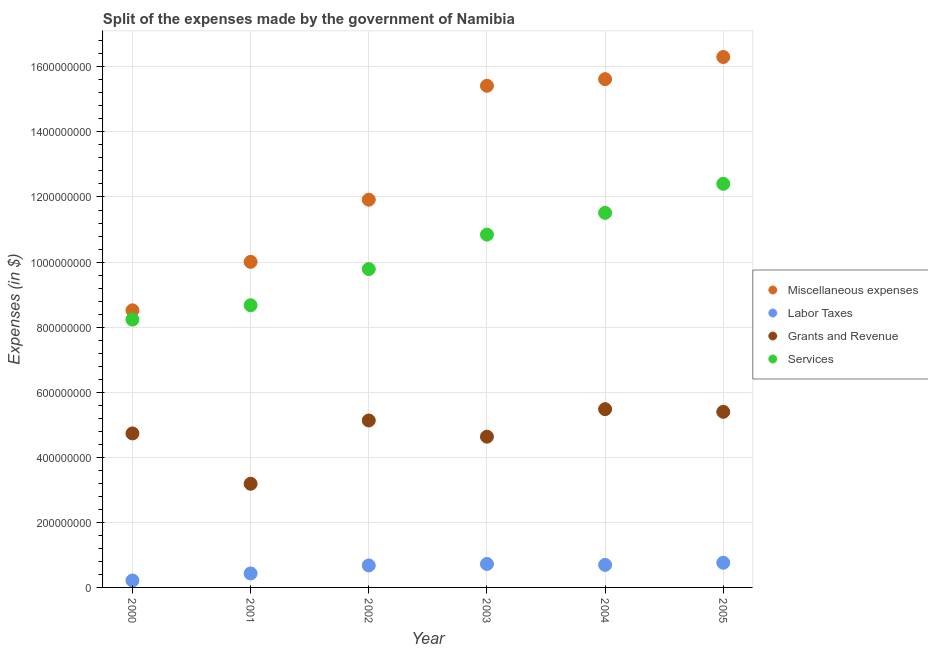Is the number of dotlines equal to the number of legend labels?
Offer a terse response. Yes. What is the amount spent on grants and revenue in 2001?
Give a very brief answer. 3.19e+08. Across all years, what is the maximum amount spent on labor taxes?
Keep it short and to the point. 7.58e+07. Across all years, what is the minimum amount spent on services?
Give a very brief answer. 8.23e+08. In which year was the amount spent on services minimum?
Make the answer very short. 2000. What is the total amount spent on miscellaneous expenses in the graph?
Your answer should be compact. 7.78e+09. What is the difference between the amount spent on services in 2000 and that in 2003?
Ensure brevity in your answer.  -2.61e+08. What is the difference between the amount spent on miscellaneous expenses in 2001 and the amount spent on grants and revenue in 2000?
Provide a succinct answer. 5.27e+08. What is the average amount spent on grants and revenue per year?
Provide a succinct answer. 4.76e+08. In the year 2004, what is the difference between the amount spent on miscellaneous expenses and amount spent on services?
Your response must be concise. 4.11e+08. In how many years, is the amount spent on services greater than 120000000 $?
Provide a short and direct response. 6. What is the ratio of the amount spent on labor taxes in 2002 to that in 2004?
Keep it short and to the point. 0.98. Is the amount spent on miscellaneous expenses in 2004 less than that in 2005?
Offer a terse response. Yes. Is the difference between the amount spent on grants and revenue in 2000 and 2005 greater than the difference between the amount spent on miscellaneous expenses in 2000 and 2005?
Offer a terse response. Yes. What is the difference between the highest and the second highest amount spent on grants and revenue?
Your answer should be very brief. 8.20e+06. What is the difference between the highest and the lowest amount spent on grants and revenue?
Keep it short and to the point. 2.29e+08. In how many years, is the amount spent on miscellaneous expenses greater than the average amount spent on miscellaneous expenses taken over all years?
Offer a terse response. 3. Is the sum of the amount spent on miscellaneous expenses in 2000 and 2005 greater than the maximum amount spent on labor taxes across all years?
Keep it short and to the point. Yes. Is it the case that in every year, the sum of the amount spent on miscellaneous expenses and amount spent on services is greater than the sum of amount spent on grants and revenue and amount spent on labor taxes?
Your answer should be very brief. No. Does the amount spent on services monotonically increase over the years?
Offer a very short reply. Yes. Is the amount spent on labor taxes strictly greater than the amount spent on services over the years?
Your response must be concise. No. How many dotlines are there?
Ensure brevity in your answer.  4. How many years are there in the graph?
Your answer should be compact. 6. Are the values on the major ticks of Y-axis written in scientific E-notation?
Give a very brief answer. No. Does the graph contain any zero values?
Provide a short and direct response. No. Where does the legend appear in the graph?
Offer a terse response. Center right. How many legend labels are there?
Offer a very short reply. 4. How are the legend labels stacked?
Ensure brevity in your answer.  Vertical. What is the title of the graph?
Provide a short and direct response. Split of the expenses made by the government of Namibia. Does "Water" appear as one of the legend labels in the graph?
Provide a succinct answer. No. What is the label or title of the X-axis?
Ensure brevity in your answer.  Year. What is the label or title of the Y-axis?
Provide a short and direct response. Expenses (in $). What is the Expenses (in $) of Miscellaneous expenses in 2000?
Keep it short and to the point. 8.52e+08. What is the Expenses (in $) in Labor Taxes in 2000?
Make the answer very short. 2.13e+07. What is the Expenses (in $) in Grants and Revenue in 2000?
Provide a succinct answer. 4.73e+08. What is the Expenses (in $) in Services in 2000?
Your answer should be compact. 8.23e+08. What is the Expenses (in $) of Miscellaneous expenses in 2001?
Your answer should be very brief. 1.00e+09. What is the Expenses (in $) in Labor Taxes in 2001?
Your answer should be very brief. 4.30e+07. What is the Expenses (in $) in Grants and Revenue in 2001?
Give a very brief answer. 3.19e+08. What is the Expenses (in $) of Services in 2001?
Your answer should be compact. 8.67e+08. What is the Expenses (in $) of Miscellaneous expenses in 2002?
Provide a short and direct response. 1.19e+09. What is the Expenses (in $) of Labor Taxes in 2002?
Ensure brevity in your answer.  6.76e+07. What is the Expenses (in $) of Grants and Revenue in 2002?
Your response must be concise. 5.13e+08. What is the Expenses (in $) in Services in 2002?
Provide a short and direct response. 9.78e+08. What is the Expenses (in $) in Miscellaneous expenses in 2003?
Your response must be concise. 1.54e+09. What is the Expenses (in $) in Labor Taxes in 2003?
Ensure brevity in your answer.  7.21e+07. What is the Expenses (in $) in Grants and Revenue in 2003?
Your response must be concise. 4.63e+08. What is the Expenses (in $) of Services in 2003?
Keep it short and to the point. 1.08e+09. What is the Expenses (in $) in Miscellaneous expenses in 2004?
Ensure brevity in your answer.  1.56e+09. What is the Expenses (in $) of Labor Taxes in 2004?
Give a very brief answer. 6.93e+07. What is the Expenses (in $) of Grants and Revenue in 2004?
Ensure brevity in your answer.  5.48e+08. What is the Expenses (in $) in Services in 2004?
Your answer should be very brief. 1.15e+09. What is the Expenses (in $) in Miscellaneous expenses in 2005?
Your response must be concise. 1.63e+09. What is the Expenses (in $) of Labor Taxes in 2005?
Your answer should be compact. 7.58e+07. What is the Expenses (in $) of Grants and Revenue in 2005?
Offer a very short reply. 5.40e+08. What is the Expenses (in $) in Services in 2005?
Make the answer very short. 1.24e+09. Across all years, what is the maximum Expenses (in $) in Miscellaneous expenses?
Your response must be concise. 1.63e+09. Across all years, what is the maximum Expenses (in $) of Labor Taxes?
Your answer should be compact. 7.58e+07. Across all years, what is the maximum Expenses (in $) of Grants and Revenue?
Your answer should be very brief. 5.48e+08. Across all years, what is the maximum Expenses (in $) in Services?
Give a very brief answer. 1.24e+09. Across all years, what is the minimum Expenses (in $) of Miscellaneous expenses?
Offer a terse response. 8.52e+08. Across all years, what is the minimum Expenses (in $) of Labor Taxes?
Ensure brevity in your answer.  2.13e+07. Across all years, what is the minimum Expenses (in $) in Grants and Revenue?
Keep it short and to the point. 3.19e+08. Across all years, what is the minimum Expenses (in $) of Services?
Your answer should be very brief. 8.23e+08. What is the total Expenses (in $) of Miscellaneous expenses in the graph?
Offer a very short reply. 7.78e+09. What is the total Expenses (in $) in Labor Taxes in the graph?
Provide a succinct answer. 3.49e+08. What is the total Expenses (in $) of Grants and Revenue in the graph?
Make the answer very short. 2.86e+09. What is the total Expenses (in $) of Services in the graph?
Ensure brevity in your answer.  6.15e+09. What is the difference between the Expenses (in $) in Miscellaneous expenses in 2000 and that in 2001?
Keep it short and to the point. -1.49e+08. What is the difference between the Expenses (in $) in Labor Taxes in 2000 and that in 2001?
Keep it short and to the point. -2.17e+07. What is the difference between the Expenses (in $) in Grants and Revenue in 2000 and that in 2001?
Your answer should be compact. 1.55e+08. What is the difference between the Expenses (in $) in Services in 2000 and that in 2001?
Give a very brief answer. -4.41e+07. What is the difference between the Expenses (in $) of Miscellaneous expenses in 2000 and that in 2002?
Provide a succinct answer. -3.40e+08. What is the difference between the Expenses (in $) of Labor Taxes in 2000 and that in 2002?
Make the answer very short. -4.63e+07. What is the difference between the Expenses (in $) of Grants and Revenue in 2000 and that in 2002?
Give a very brief answer. -3.98e+07. What is the difference between the Expenses (in $) of Services in 2000 and that in 2002?
Your answer should be very brief. -1.55e+08. What is the difference between the Expenses (in $) of Miscellaneous expenses in 2000 and that in 2003?
Provide a succinct answer. -6.90e+08. What is the difference between the Expenses (in $) of Labor Taxes in 2000 and that in 2003?
Your answer should be compact. -5.08e+07. What is the difference between the Expenses (in $) of Grants and Revenue in 2000 and that in 2003?
Offer a very short reply. 1.00e+07. What is the difference between the Expenses (in $) of Services in 2000 and that in 2003?
Your response must be concise. -2.61e+08. What is the difference between the Expenses (in $) of Miscellaneous expenses in 2000 and that in 2004?
Ensure brevity in your answer.  -7.11e+08. What is the difference between the Expenses (in $) of Labor Taxes in 2000 and that in 2004?
Provide a short and direct response. -4.80e+07. What is the difference between the Expenses (in $) in Grants and Revenue in 2000 and that in 2004?
Offer a very short reply. -7.46e+07. What is the difference between the Expenses (in $) of Services in 2000 and that in 2004?
Your response must be concise. -3.28e+08. What is the difference between the Expenses (in $) of Miscellaneous expenses in 2000 and that in 2005?
Keep it short and to the point. -7.79e+08. What is the difference between the Expenses (in $) of Labor Taxes in 2000 and that in 2005?
Your response must be concise. -5.45e+07. What is the difference between the Expenses (in $) of Grants and Revenue in 2000 and that in 2005?
Provide a short and direct response. -6.64e+07. What is the difference between the Expenses (in $) of Services in 2000 and that in 2005?
Provide a short and direct response. -4.17e+08. What is the difference between the Expenses (in $) in Miscellaneous expenses in 2001 and that in 2002?
Make the answer very short. -1.91e+08. What is the difference between the Expenses (in $) of Labor Taxes in 2001 and that in 2002?
Provide a succinct answer. -2.46e+07. What is the difference between the Expenses (in $) of Grants and Revenue in 2001 and that in 2002?
Make the answer very short. -1.94e+08. What is the difference between the Expenses (in $) in Services in 2001 and that in 2002?
Provide a succinct answer. -1.11e+08. What is the difference between the Expenses (in $) of Miscellaneous expenses in 2001 and that in 2003?
Offer a terse response. -5.41e+08. What is the difference between the Expenses (in $) of Labor Taxes in 2001 and that in 2003?
Keep it short and to the point. -2.91e+07. What is the difference between the Expenses (in $) of Grants and Revenue in 2001 and that in 2003?
Your answer should be compact. -1.45e+08. What is the difference between the Expenses (in $) in Services in 2001 and that in 2003?
Give a very brief answer. -2.17e+08. What is the difference between the Expenses (in $) of Miscellaneous expenses in 2001 and that in 2004?
Your answer should be compact. -5.62e+08. What is the difference between the Expenses (in $) in Labor Taxes in 2001 and that in 2004?
Your response must be concise. -2.63e+07. What is the difference between the Expenses (in $) in Grants and Revenue in 2001 and that in 2004?
Provide a short and direct response. -2.29e+08. What is the difference between the Expenses (in $) of Services in 2001 and that in 2004?
Your response must be concise. -2.84e+08. What is the difference between the Expenses (in $) in Miscellaneous expenses in 2001 and that in 2005?
Provide a short and direct response. -6.30e+08. What is the difference between the Expenses (in $) in Labor Taxes in 2001 and that in 2005?
Your response must be concise. -3.28e+07. What is the difference between the Expenses (in $) of Grants and Revenue in 2001 and that in 2005?
Ensure brevity in your answer.  -2.21e+08. What is the difference between the Expenses (in $) of Services in 2001 and that in 2005?
Give a very brief answer. -3.73e+08. What is the difference between the Expenses (in $) in Miscellaneous expenses in 2002 and that in 2003?
Offer a terse response. -3.50e+08. What is the difference between the Expenses (in $) of Labor Taxes in 2002 and that in 2003?
Offer a very short reply. -4.50e+06. What is the difference between the Expenses (in $) in Grants and Revenue in 2002 and that in 2003?
Give a very brief answer. 4.98e+07. What is the difference between the Expenses (in $) in Services in 2002 and that in 2003?
Your answer should be compact. -1.06e+08. What is the difference between the Expenses (in $) of Miscellaneous expenses in 2002 and that in 2004?
Offer a terse response. -3.71e+08. What is the difference between the Expenses (in $) of Labor Taxes in 2002 and that in 2004?
Offer a very short reply. -1.70e+06. What is the difference between the Expenses (in $) of Grants and Revenue in 2002 and that in 2004?
Give a very brief answer. -3.48e+07. What is the difference between the Expenses (in $) of Services in 2002 and that in 2004?
Provide a succinct answer. -1.73e+08. What is the difference between the Expenses (in $) in Miscellaneous expenses in 2002 and that in 2005?
Provide a succinct answer. -4.39e+08. What is the difference between the Expenses (in $) in Labor Taxes in 2002 and that in 2005?
Your answer should be very brief. -8.20e+06. What is the difference between the Expenses (in $) of Grants and Revenue in 2002 and that in 2005?
Provide a succinct answer. -2.66e+07. What is the difference between the Expenses (in $) in Services in 2002 and that in 2005?
Provide a succinct answer. -2.62e+08. What is the difference between the Expenses (in $) in Miscellaneous expenses in 2003 and that in 2004?
Offer a terse response. -2.04e+07. What is the difference between the Expenses (in $) of Labor Taxes in 2003 and that in 2004?
Your answer should be very brief. 2.80e+06. What is the difference between the Expenses (in $) in Grants and Revenue in 2003 and that in 2004?
Make the answer very short. -8.46e+07. What is the difference between the Expenses (in $) in Services in 2003 and that in 2004?
Provide a short and direct response. -6.68e+07. What is the difference between the Expenses (in $) of Miscellaneous expenses in 2003 and that in 2005?
Offer a very short reply. -8.84e+07. What is the difference between the Expenses (in $) in Labor Taxes in 2003 and that in 2005?
Offer a very short reply. -3.70e+06. What is the difference between the Expenses (in $) of Grants and Revenue in 2003 and that in 2005?
Provide a succinct answer. -7.64e+07. What is the difference between the Expenses (in $) of Services in 2003 and that in 2005?
Make the answer very short. -1.56e+08. What is the difference between the Expenses (in $) in Miscellaneous expenses in 2004 and that in 2005?
Offer a very short reply. -6.80e+07. What is the difference between the Expenses (in $) in Labor Taxes in 2004 and that in 2005?
Provide a succinct answer. -6.50e+06. What is the difference between the Expenses (in $) of Grants and Revenue in 2004 and that in 2005?
Make the answer very short. 8.20e+06. What is the difference between the Expenses (in $) in Services in 2004 and that in 2005?
Your answer should be compact. -8.94e+07. What is the difference between the Expenses (in $) of Miscellaneous expenses in 2000 and the Expenses (in $) of Labor Taxes in 2001?
Give a very brief answer. 8.09e+08. What is the difference between the Expenses (in $) of Miscellaneous expenses in 2000 and the Expenses (in $) of Grants and Revenue in 2001?
Keep it short and to the point. 5.33e+08. What is the difference between the Expenses (in $) in Miscellaneous expenses in 2000 and the Expenses (in $) in Services in 2001?
Make the answer very short. -1.56e+07. What is the difference between the Expenses (in $) of Labor Taxes in 2000 and the Expenses (in $) of Grants and Revenue in 2001?
Your answer should be very brief. -2.97e+08. What is the difference between the Expenses (in $) in Labor Taxes in 2000 and the Expenses (in $) in Services in 2001?
Your answer should be compact. -8.46e+08. What is the difference between the Expenses (in $) in Grants and Revenue in 2000 and the Expenses (in $) in Services in 2001?
Your answer should be very brief. -3.94e+08. What is the difference between the Expenses (in $) in Miscellaneous expenses in 2000 and the Expenses (in $) in Labor Taxes in 2002?
Keep it short and to the point. 7.84e+08. What is the difference between the Expenses (in $) in Miscellaneous expenses in 2000 and the Expenses (in $) in Grants and Revenue in 2002?
Keep it short and to the point. 3.39e+08. What is the difference between the Expenses (in $) in Miscellaneous expenses in 2000 and the Expenses (in $) in Services in 2002?
Offer a very short reply. -1.27e+08. What is the difference between the Expenses (in $) of Labor Taxes in 2000 and the Expenses (in $) of Grants and Revenue in 2002?
Ensure brevity in your answer.  -4.92e+08. What is the difference between the Expenses (in $) of Labor Taxes in 2000 and the Expenses (in $) of Services in 2002?
Make the answer very short. -9.57e+08. What is the difference between the Expenses (in $) of Grants and Revenue in 2000 and the Expenses (in $) of Services in 2002?
Give a very brief answer. -5.05e+08. What is the difference between the Expenses (in $) in Miscellaneous expenses in 2000 and the Expenses (in $) in Labor Taxes in 2003?
Keep it short and to the point. 7.80e+08. What is the difference between the Expenses (in $) of Miscellaneous expenses in 2000 and the Expenses (in $) of Grants and Revenue in 2003?
Provide a succinct answer. 3.88e+08. What is the difference between the Expenses (in $) of Miscellaneous expenses in 2000 and the Expenses (in $) of Services in 2003?
Offer a very short reply. -2.33e+08. What is the difference between the Expenses (in $) in Labor Taxes in 2000 and the Expenses (in $) in Grants and Revenue in 2003?
Ensure brevity in your answer.  -4.42e+08. What is the difference between the Expenses (in $) of Labor Taxes in 2000 and the Expenses (in $) of Services in 2003?
Your answer should be compact. -1.06e+09. What is the difference between the Expenses (in $) in Grants and Revenue in 2000 and the Expenses (in $) in Services in 2003?
Offer a very short reply. -6.11e+08. What is the difference between the Expenses (in $) in Miscellaneous expenses in 2000 and the Expenses (in $) in Labor Taxes in 2004?
Your answer should be compact. 7.82e+08. What is the difference between the Expenses (in $) in Miscellaneous expenses in 2000 and the Expenses (in $) in Grants and Revenue in 2004?
Give a very brief answer. 3.04e+08. What is the difference between the Expenses (in $) in Miscellaneous expenses in 2000 and the Expenses (in $) in Services in 2004?
Provide a short and direct response. -3.00e+08. What is the difference between the Expenses (in $) of Labor Taxes in 2000 and the Expenses (in $) of Grants and Revenue in 2004?
Your answer should be compact. -5.27e+08. What is the difference between the Expenses (in $) in Labor Taxes in 2000 and the Expenses (in $) in Services in 2004?
Provide a succinct answer. -1.13e+09. What is the difference between the Expenses (in $) in Grants and Revenue in 2000 and the Expenses (in $) in Services in 2004?
Your response must be concise. -6.78e+08. What is the difference between the Expenses (in $) in Miscellaneous expenses in 2000 and the Expenses (in $) in Labor Taxes in 2005?
Your answer should be very brief. 7.76e+08. What is the difference between the Expenses (in $) in Miscellaneous expenses in 2000 and the Expenses (in $) in Grants and Revenue in 2005?
Provide a short and direct response. 3.12e+08. What is the difference between the Expenses (in $) in Miscellaneous expenses in 2000 and the Expenses (in $) in Services in 2005?
Offer a terse response. -3.89e+08. What is the difference between the Expenses (in $) of Labor Taxes in 2000 and the Expenses (in $) of Grants and Revenue in 2005?
Your response must be concise. -5.18e+08. What is the difference between the Expenses (in $) in Labor Taxes in 2000 and the Expenses (in $) in Services in 2005?
Ensure brevity in your answer.  -1.22e+09. What is the difference between the Expenses (in $) of Grants and Revenue in 2000 and the Expenses (in $) of Services in 2005?
Keep it short and to the point. -7.67e+08. What is the difference between the Expenses (in $) in Miscellaneous expenses in 2001 and the Expenses (in $) in Labor Taxes in 2002?
Your answer should be compact. 9.33e+08. What is the difference between the Expenses (in $) in Miscellaneous expenses in 2001 and the Expenses (in $) in Grants and Revenue in 2002?
Make the answer very short. 4.88e+08. What is the difference between the Expenses (in $) in Miscellaneous expenses in 2001 and the Expenses (in $) in Services in 2002?
Your response must be concise. 2.22e+07. What is the difference between the Expenses (in $) in Labor Taxes in 2001 and the Expenses (in $) in Grants and Revenue in 2002?
Your answer should be compact. -4.70e+08. What is the difference between the Expenses (in $) in Labor Taxes in 2001 and the Expenses (in $) in Services in 2002?
Keep it short and to the point. -9.36e+08. What is the difference between the Expenses (in $) in Grants and Revenue in 2001 and the Expenses (in $) in Services in 2002?
Your response must be concise. -6.60e+08. What is the difference between the Expenses (in $) in Miscellaneous expenses in 2001 and the Expenses (in $) in Labor Taxes in 2003?
Give a very brief answer. 9.29e+08. What is the difference between the Expenses (in $) in Miscellaneous expenses in 2001 and the Expenses (in $) in Grants and Revenue in 2003?
Your answer should be compact. 5.37e+08. What is the difference between the Expenses (in $) of Miscellaneous expenses in 2001 and the Expenses (in $) of Services in 2003?
Provide a succinct answer. -8.37e+07. What is the difference between the Expenses (in $) in Labor Taxes in 2001 and the Expenses (in $) in Grants and Revenue in 2003?
Provide a short and direct response. -4.20e+08. What is the difference between the Expenses (in $) of Labor Taxes in 2001 and the Expenses (in $) of Services in 2003?
Give a very brief answer. -1.04e+09. What is the difference between the Expenses (in $) in Grants and Revenue in 2001 and the Expenses (in $) in Services in 2003?
Your response must be concise. -7.66e+08. What is the difference between the Expenses (in $) in Miscellaneous expenses in 2001 and the Expenses (in $) in Labor Taxes in 2004?
Ensure brevity in your answer.  9.31e+08. What is the difference between the Expenses (in $) of Miscellaneous expenses in 2001 and the Expenses (in $) of Grants and Revenue in 2004?
Provide a succinct answer. 4.53e+08. What is the difference between the Expenses (in $) of Miscellaneous expenses in 2001 and the Expenses (in $) of Services in 2004?
Keep it short and to the point. -1.51e+08. What is the difference between the Expenses (in $) of Labor Taxes in 2001 and the Expenses (in $) of Grants and Revenue in 2004?
Make the answer very short. -5.05e+08. What is the difference between the Expenses (in $) of Labor Taxes in 2001 and the Expenses (in $) of Services in 2004?
Ensure brevity in your answer.  -1.11e+09. What is the difference between the Expenses (in $) in Grants and Revenue in 2001 and the Expenses (in $) in Services in 2004?
Provide a short and direct response. -8.33e+08. What is the difference between the Expenses (in $) in Miscellaneous expenses in 2001 and the Expenses (in $) in Labor Taxes in 2005?
Your answer should be compact. 9.25e+08. What is the difference between the Expenses (in $) of Miscellaneous expenses in 2001 and the Expenses (in $) of Grants and Revenue in 2005?
Offer a very short reply. 4.61e+08. What is the difference between the Expenses (in $) of Miscellaneous expenses in 2001 and the Expenses (in $) of Services in 2005?
Make the answer very short. -2.40e+08. What is the difference between the Expenses (in $) in Labor Taxes in 2001 and the Expenses (in $) in Grants and Revenue in 2005?
Keep it short and to the point. -4.97e+08. What is the difference between the Expenses (in $) of Labor Taxes in 2001 and the Expenses (in $) of Services in 2005?
Offer a very short reply. -1.20e+09. What is the difference between the Expenses (in $) of Grants and Revenue in 2001 and the Expenses (in $) of Services in 2005?
Offer a terse response. -9.22e+08. What is the difference between the Expenses (in $) of Miscellaneous expenses in 2002 and the Expenses (in $) of Labor Taxes in 2003?
Provide a short and direct response. 1.12e+09. What is the difference between the Expenses (in $) of Miscellaneous expenses in 2002 and the Expenses (in $) of Grants and Revenue in 2003?
Give a very brief answer. 7.28e+08. What is the difference between the Expenses (in $) of Miscellaneous expenses in 2002 and the Expenses (in $) of Services in 2003?
Make the answer very short. 1.07e+08. What is the difference between the Expenses (in $) in Labor Taxes in 2002 and the Expenses (in $) in Grants and Revenue in 2003?
Offer a very short reply. -3.96e+08. What is the difference between the Expenses (in $) in Labor Taxes in 2002 and the Expenses (in $) in Services in 2003?
Offer a very short reply. -1.02e+09. What is the difference between the Expenses (in $) in Grants and Revenue in 2002 and the Expenses (in $) in Services in 2003?
Give a very brief answer. -5.71e+08. What is the difference between the Expenses (in $) in Miscellaneous expenses in 2002 and the Expenses (in $) in Labor Taxes in 2004?
Ensure brevity in your answer.  1.12e+09. What is the difference between the Expenses (in $) of Miscellaneous expenses in 2002 and the Expenses (in $) of Grants and Revenue in 2004?
Make the answer very short. 6.44e+08. What is the difference between the Expenses (in $) of Miscellaneous expenses in 2002 and the Expenses (in $) of Services in 2004?
Your response must be concise. 4.05e+07. What is the difference between the Expenses (in $) in Labor Taxes in 2002 and the Expenses (in $) in Grants and Revenue in 2004?
Make the answer very short. -4.80e+08. What is the difference between the Expenses (in $) of Labor Taxes in 2002 and the Expenses (in $) of Services in 2004?
Your answer should be compact. -1.08e+09. What is the difference between the Expenses (in $) of Grants and Revenue in 2002 and the Expenses (in $) of Services in 2004?
Your response must be concise. -6.38e+08. What is the difference between the Expenses (in $) in Miscellaneous expenses in 2002 and the Expenses (in $) in Labor Taxes in 2005?
Offer a terse response. 1.12e+09. What is the difference between the Expenses (in $) of Miscellaneous expenses in 2002 and the Expenses (in $) of Grants and Revenue in 2005?
Your answer should be very brief. 6.52e+08. What is the difference between the Expenses (in $) in Miscellaneous expenses in 2002 and the Expenses (in $) in Services in 2005?
Offer a very short reply. -4.89e+07. What is the difference between the Expenses (in $) of Labor Taxes in 2002 and the Expenses (in $) of Grants and Revenue in 2005?
Provide a short and direct response. -4.72e+08. What is the difference between the Expenses (in $) in Labor Taxes in 2002 and the Expenses (in $) in Services in 2005?
Offer a very short reply. -1.17e+09. What is the difference between the Expenses (in $) in Grants and Revenue in 2002 and the Expenses (in $) in Services in 2005?
Your response must be concise. -7.28e+08. What is the difference between the Expenses (in $) in Miscellaneous expenses in 2003 and the Expenses (in $) in Labor Taxes in 2004?
Make the answer very short. 1.47e+09. What is the difference between the Expenses (in $) of Miscellaneous expenses in 2003 and the Expenses (in $) of Grants and Revenue in 2004?
Offer a very short reply. 9.94e+08. What is the difference between the Expenses (in $) in Miscellaneous expenses in 2003 and the Expenses (in $) in Services in 2004?
Offer a terse response. 3.91e+08. What is the difference between the Expenses (in $) of Labor Taxes in 2003 and the Expenses (in $) of Grants and Revenue in 2004?
Keep it short and to the point. -4.76e+08. What is the difference between the Expenses (in $) of Labor Taxes in 2003 and the Expenses (in $) of Services in 2004?
Provide a succinct answer. -1.08e+09. What is the difference between the Expenses (in $) in Grants and Revenue in 2003 and the Expenses (in $) in Services in 2004?
Keep it short and to the point. -6.88e+08. What is the difference between the Expenses (in $) in Miscellaneous expenses in 2003 and the Expenses (in $) in Labor Taxes in 2005?
Provide a short and direct response. 1.47e+09. What is the difference between the Expenses (in $) in Miscellaneous expenses in 2003 and the Expenses (in $) in Grants and Revenue in 2005?
Make the answer very short. 1.00e+09. What is the difference between the Expenses (in $) in Miscellaneous expenses in 2003 and the Expenses (in $) in Services in 2005?
Provide a succinct answer. 3.01e+08. What is the difference between the Expenses (in $) of Labor Taxes in 2003 and the Expenses (in $) of Grants and Revenue in 2005?
Make the answer very short. -4.68e+08. What is the difference between the Expenses (in $) of Labor Taxes in 2003 and the Expenses (in $) of Services in 2005?
Your response must be concise. -1.17e+09. What is the difference between the Expenses (in $) in Grants and Revenue in 2003 and the Expenses (in $) in Services in 2005?
Provide a short and direct response. -7.77e+08. What is the difference between the Expenses (in $) in Miscellaneous expenses in 2004 and the Expenses (in $) in Labor Taxes in 2005?
Make the answer very short. 1.49e+09. What is the difference between the Expenses (in $) in Miscellaneous expenses in 2004 and the Expenses (in $) in Grants and Revenue in 2005?
Offer a terse response. 1.02e+09. What is the difference between the Expenses (in $) of Miscellaneous expenses in 2004 and the Expenses (in $) of Services in 2005?
Provide a short and direct response. 3.22e+08. What is the difference between the Expenses (in $) in Labor Taxes in 2004 and the Expenses (in $) in Grants and Revenue in 2005?
Your response must be concise. -4.70e+08. What is the difference between the Expenses (in $) of Labor Taxes in 2004 and the Expenses (in $) of Services in 2005?
Keep it short and to the point. -1.17e+09. What is the difference between the Expenses (in $) in Grants and Revenue in 2004 and the Expenses (in $) in Services in 2005?
Offer a terse response. -6.93e+08. What is the average Expenses (in $) of Miscellaneous expenses per year?
Your answer should be very brief. 1.30e+09. What is the average Expenses (in $) of Labor Taxes per year?
Make the answer very short. 5.82e+07. What is the average Expenses (in $) of Grants and Revenue per year?
Provide a succinct answer. 4.76e+08. What is the average Expenses (in $) in Services per year?
Offer a very short reply. 1.02e+09. In the year 2000, what is the difference between the Expenses (in $) in Miscellaneous expenses and Expenses (in $) in Labor Taxes?
Give a very brief answer. 8.30e+08. In the year 2000, what is the difference between the Expenses (in $) in Miscellaneous expenses and Expenses (in $) in Grants and Revenue?
Offer a terse response. 3.78e+08. In the year 2000, what is the difference between the Expenses (in $) in Miscellaneous expenses and Expenses (in $) in Services?
Make the answer very short. 2.85e+07. In the year 2000, what is the difference between the Expenses (in $) of Labor Taxes and Expenses (in $) of Grants and Revenue?
Make the answer very short. -4.52e+08. In the year 2000, what is the difference between the Expenses (in $) in Labor Taxes and Expenses (in $) in Services?
Your response must be concise. -8.02e+08. In the year 2000, what is the difference between the Expenses (in $) of Grants and Revenue and Expenses (in $) of Services?
Give a very brief answer. -3.50e+08. In the year 2001, what is the difference between the Expenses (in $) of Miscellaneous expenses and Expenses (in $) of Labor Taxes?
Keep it short and to the point. 9.58e+08. In the year 2001, what is the difference between the Expenses (in $) of Miscellaneous expenses and Expenses (in $) of Grants and Revenue?
Make the answer very short. 6.82e+08. In the year 2001, what is the difference between the Expenses (in $) in Miscellaneous expenses and Expenses (in $) in Services?
Ensure brevity in your answer.  1.33e+08. In the year 2001, what is the difference between the Expenses (in $) of Labor Taxes and Expenses (in $) of Grants and Revenue?
Offer a very short reply. -2.76e+08. In the year 2001, what is the difference between the Expenses (in $) in Labor Taxes and Expenses (in $) in Services?
Provide a succinct answer. -8.24e+08. In the year 2001, what is the difference between the Expenses (in $) in Grants and Revenue and Expenses (in $) in Services?
Provide a short and direct response. -5.49e+08. In the year 2002, what is the difference between the Expenses (in $) in Miscellaneous expenses and Expenses (in $) in Labor Taxes?
Offer a very short reply. 1.12e+09. In the year 2002, what is the difference between the Expenses (in $) in Miscellaneous expenses and Expenses (in $) in Grants and Revenue?
Your response must be concise. 6.79e+08. In the year 2002, what is the difference between the Expenses (in $) in Miscellaneous expenses and Expenses (in $) in Services?
Ensure brevity in your answer.  2.13e+08. In the year 2002, what is the difference between the Expenses (in $) in Labor Taxes and Expenses (in $) in Grants and Revenue?
Offer a very short reply. -4.46e+08. In the year 2002, what is the difference between the Expenses (in $) in Labor Taxes and Expenses (in $) in Services?
Your answer should be very brief. -9.11e+08. In the year 2002, what is the difference between the Expenses (in $) of Grants and Revenue and Expenses (in $) of Services?
Provide a succinct answer. -4.65e+08. In the year 2003, what is the difference between the Expenses (in $) in Miscellaneous expenses and Expenses (in $) in Labor Taxes?
Your answer should be very brief. 1.47e+09. In the year 2003, what is the difference between the Expenses (in $) of Miscellaneous expenses and Expenses (in $) of Grants and Revenue?
Your answer should be very brief. 1.08e+09. In the year 2003, what is the difference between the Expenses (in $) in Miscellaneous expenses and Expenses (in $) in Services?
Offer a terse response. 4.57e+08. In the year 2003, what is the difference between the Expenses (in $) in Labor Taxes and Expenses (in $) in Grants and Revenue?
Offer a terse response. -3.91e+08. In the year 2003, what is the difference between the Expenses (in $) in Labor Taxes and Expenses (in $) in Services?
Give a very brief answer. -1.01e+09. In the year 2003, what is the difference between the Expenses (in $) of Grants and Revenue and Expenses (in $) of Services?
Keep it short and to the point. -6.21e+08. In the year 2004, what is the difference between the Expenses (in $) in Miscellaneous expenses and Expenses (in $) in Labor Taxes?
Offer a terse response. 1.49e+09. In the year 2004, what is the difference between the Expenses (in $) of Miscellaneous expenses and Expenses (in $) of Grants and Revenue?
Ensure brevity in your answer.  1.01e+09. In the year 2004, what is the difference between the Expenses (in $) of Miscellaneous expenses and Expenses (in $) of Services?
Your response must be concise. 4.11e+08. In the year 2004, what is the difference between the Expenses (in $) in Labor Taxes and Expenses (in $) in Grants and Revenue?
Your answer should be very brief. -4.79e+08. In the year 2004, what is the difference between the Expenses (in $) in Labor Taxes and Expenses (in $) in Services?
Provide a succinct answer. -1.08e+09. In the year 2004, what is the difference between the Expenses (in $) of Grants and Revenue and Expenses (in $) of Services?
Your response must be concise. -6.03e+08. In the year 2005, what is the difference between the Expenses (in $) of Miscellaneous expenses and Expenses (in $) of Labor Taxes?
Give a very brief answer. 1.55e+09. In the year 2005, what is the difference between the Expenses (in $) of Miscellaneous expenses and Expenses (in $) of Grants and Revenue?
Make the answer very short. 1.09e+09. In the year 2005, what is the difference between the Expenses (in $) in Miscellaneous expenses and Expenses (in $) in Services?
Your response must be concise. 3.90e+08. In the year 2005, what is the difference between the Expenses (in $) in Labor Taxes and Expenses (in $) in Grants and Revenue?
Keep it short and to the point. -4.64e+08. In the year 2005, what is the difference between the Expenses (in $) of Labor Taxes and Expenses (in $) of Services?
Provide a short and direct response. -1.16e+09. In the year 2005, what is the difference between the Expenses (in $) of Grants and Revenue and Expenses (in $) of Services?
Make the answer very short. -7.01e+08. What is the ratio of the Expenses (in $) of Miscellaneous expenses in 2000 to that in 2001?
Your response must be concise. 0.85. What is the ratio of the Expenses (in $) in Labor Taxes in 2000 to that in 2001?
Give a very brief answer. 0.5. What is the ratio of the Expenses (in $) of Grants and Revenue in 2000 to that in 2001?
Offer a very short reply. 1.49. What is the ratio of the Expenses (in $) in Services in 2000 to that in 2001?
Your response must be concise. 0.95. What is the ratio of the Expenses (in $) of Miscellaneous expenses in 2000 to that in 2002?
Ensure brevity in your answer.  0.71. What is the ratio of the Expenses (in $) in Labor Taxes in 2000 to that in 2002?
Ensure brevity in your answer.  0.32. What is the ratio of the Expenses (in $) of Grants and Revenue in 2000 to that in 2002?
Your answer should be compact. 0.92. What is the ratio of the Expenses (in $) in Services in 2000 to that in 2002?
Offer a terse response. 0.84. What is the ratio of the Expenses (in $) of Miscellaneous expenses in 2000 to that in 2003?
Your answer should be very brief. 0.55. What is the ratio of the Expenses (in $) of Labor Taxes in 2000 to that in 2003?
Offer a terse response. 0.3. What is the ratio of the Expenses (in $) of Grants and Revenue in 2000 to that in 2003?
Make the answer very short. 1.02. What is the ratio of the Expenses (in $) in Services in 2000 to that in 2003?
Keep it short and to the point. 0.76. What is the ratio of the Expenses (in $) in Miscellaneous expenses in 2000 to that in 2004?
Your answer should be compact. 0.55. What is the ratio of the Expenses (in $) of Labor Taxes in 2000 to that in 2004?
Your response must be concise. 0.31. What is the ratio of the Expenses (in $) in Grants and Revenue in 2000 to that in 2004?
Give a very brief answer. 0.86. What is the ratio of the Expenses (in $) of Services in 2000 to that in 2004?
Offer a very short reply. 0.72. What is the ratio of the Expenses (in $) of Miscellaneous expenses in 2000 to that in 2005?
Offer a very short reply. 0.52. What is the ratio of the Expenses (in $) of Labor Taxes in 2000 to that in 2005?
Give a very brief answer. 0.28. What is the ratio of the Expenses (in $) of Grants and Revenue in 2000 to that in 2005?
Your answer should be very brief. 0.88. What is the ratio of the Expenses (in $) in Services in 2000 to that in 2005?
Provide a succinct answer. 0.66. What is the ratio of the Expenses (in $) in Miscellaneous expenses in 2001 to that in 2002?
Give a very brief answer. 0.84. What is the ratio of the Expenses (in $) in Labor Taxes in 2001 to that in 2002?
Provide a succinct answer. 0.64. What is the ratio of the Expenses (in $) in Grants and Revenue in 2001 to that in 2002?
Offer a very short reply. 0.62. What is the ratio of the Expenses (in $) in Services in 2001 to that in 2002?
Your answer should be compact. 0.89. What is the ratio of the Expenses (in $) in Miscellaneous expenses in 2001 to that in 2003?
Offer a terse response. 0.65. What is the ratio of the Expenses (in $) of Labor Taxes in 2001 to that in 2003?
Give a very brief answer. 0.6. What is the ratio of the Expenses (in $) of Grants and Revenue in 2001 to that in 2003?
Keep it short and to the point. 0.69. What is the ratio of the Expenses (in $) in Services in 2001 to that in 2003?
Your answer should be very brief. 0.8. What is the ratio of the Expenses (in $) of Miscellaneous expenses in 2001 to that in 2004?
Provide a succinct answer. 0.64. What is the ratio of the Expenses (in $) in Labor Taxes in 2001 to that in 2004?
Ensure brevity in your answer.  0.62. What is the ratio of the Expenses (in $) of Grants and Revenue in 2001 to that in 2004?
Provide a short and direct response. 0.58. What is the ratio of the Expenses (in $) in Services in 2001 to that in 2004?
Your answer should be very brief. 0.75. What is the ratio of the Expenses (in $) of Miscellaneous expenses in 2001 to that in 2005?
Make the answer very short. 0.61. What is the ratio of the Expenses (in $) of Labor Taxes in 2001 to that in 2005?
Your response must be concise. 0.57. What is the ratio of the Expenses (in $) of Grants and Revenue in 2001 to that in 2005?
Provide a succinct answer. 0.59. What is the ratio of the Expenses (in $) of Services in 2001 to that in 2005?
Offer a very short reply. 0.7. What is the ratio of the Expenses (in $) in Miscellaneous expenses in 2002 to that in 2003?
Give a very brief answer. 0.77. What is the ratio of the Expenses (in $) of Labor Taxes in 2002 to that in 2003?
Your answer should be very brief. 0.94. What is the ratio of the Expenses (in $) of Grants and Revenue in 2002 to that in 2003?
Ensure brevity in your answer.  1.11. What is the ratio of the Expenses (in $) of Services in 2002 to that in 2003?
Your answer should be compact. 0.9. What is the ratio of the Expenses (in $) of Miscellaneous expenses in 2002 to that in 2004?
Your answer should be very brief. 0.76. What is the ratio of the Expenses (in $) in Labor Taxes in 2002 to that in 2004?
Your answer should be very brief. 0.98. What is the ratio of the Expenses (in $) in Grants and Revenue in 2002 to that in 2004?
Give a very brief answer. 0.94. What is the ratio of the Expenses (in $) in Services in 2002 to that in 2004?
Ensure brevity in your answer.  0.85. What is the ratio of the Expenses (in $) of Miscellaneous expenses in 2002 to that in 2005?
Give a very brief answer. 0.73. What is the ratio of the Expenses (in $) in Labor Taxes in 2002 to that in 2005?
Give a very brief answer. 0.89. What is the ratio of the Expenses (in $) of Grants and Revenue in 2002 to that in 2005?
Your response must be concise. 0.95. What is the ratio of the Expenses (in $) in Services in 2002 to that in 2005?
Give a very brief answer. 0.79. What is the ratio of the Expenses (in $) of Labor Taxes in 2003 to that in 2004?
Your answer should be compact. 1.04. What is the ratio of the Expenses (in $) of Grants and Revenue in 2003 to that in 2004?
Provide a succinct answer. 0.85. What is the ratio of the Expenses (in $) in Services in 2003 to that in 2004?
Your answer should be very brief. 0.94. What is the ratio of the Expenses (in $) of Miscellaneous expenses in 2003 to that in 2005?
Provide a short and direct response. 0.95. What is the ratio of the Expenses (in $) in Labor Taxes in 2003 to that in 2005?
Provide a succinct answer. 0.95. What is the ratio of the Expenses (in $) of Grants and Revenue in 2003 to that in 2005?
Your response must be concise. 0.86. What is the ratio of the Expenses (in $) of Services in 2003 to that in 2005?
Give a very brief answer. 0.87. What is the ratio of the Expenses (in $) of Miscellaneous expenses in 2004 to that in 2005?
Offer a very short reply. 0.96. What is the ratio of the Expenses (in $) of Labor Taxes in 2004 to that in 2005?
Offer a very short reply. 0.91. What is the ratio of the Expenses (in $) of Grants and Revenue in 2004 to that in 2005?
Your answer should be compact. 1.02. What is the ratio of the Expenses (in $) of Services in 2004 to that in 2005?
Your response must be concise. 0.93. What is the difference between the highest and the second highest Expenses (in $) of Miscellaneous expenses?
Your answer should be very brief. 6.80e+07. What is the difference between the highest and the second highest Expenses (in $) in Labor Taxes?
Give a very brief answer. 3.70e+06. What is the difference between the highest and the second highest Expenses (in $) in Grants and Revenue?
Provide a short and direct response. 8.20e+06. What is the difference between the highest and the second highest Expenses (in $) of Services?
Your answer should be very brief. 8.94e+07. What is the difference between the highest and the lowest Expenses (in $) in Miscellaneous expenses?
Make the answer very short. 7.79e+08. What is the difference between the highest and the lowest Expenses (in $) in Labor Taxes?
Provide a short and direct response. 5.45e+07. What is the difference between the highest and the lowest Expenses (in $) of Grants and Revenue?
Your answer should be very brief. 2.29e+08. What is the difference between the highest and the lowest Expenses (in $) in Services?
Ensure brevity in your answer.  4.17e+08. 